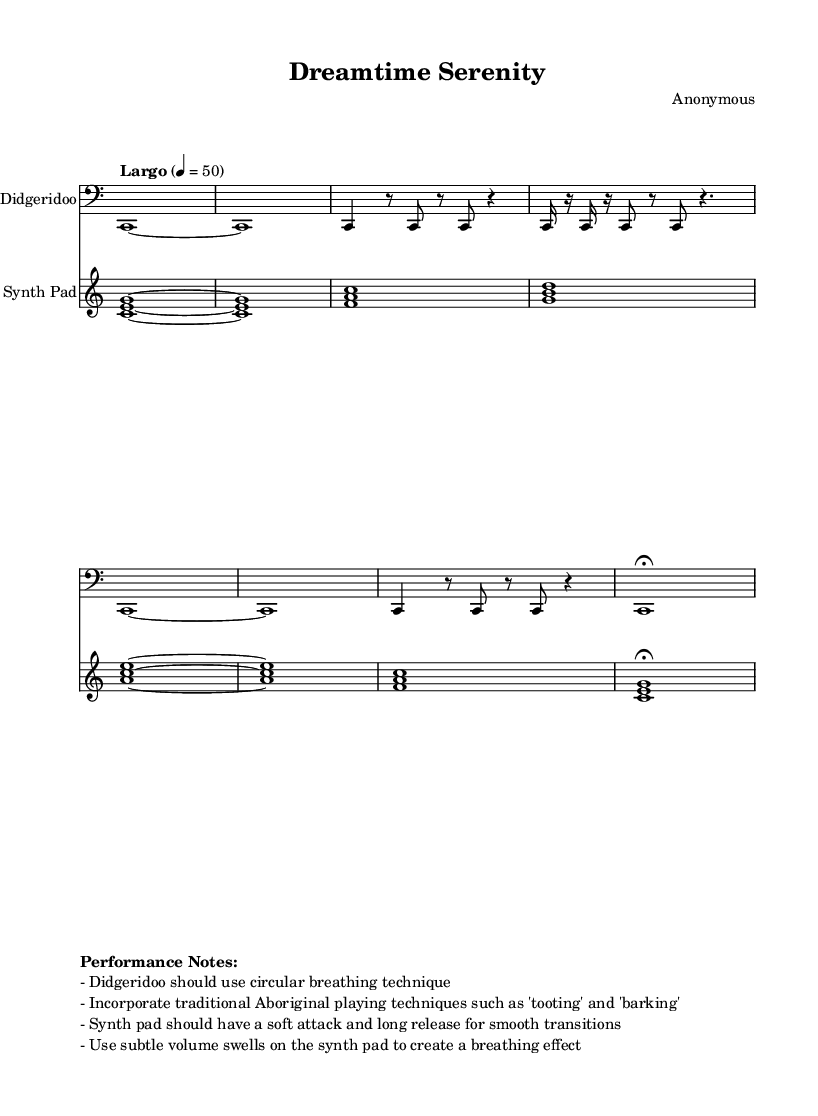What is the time signature of this music? The time signature is indicated at the beginning of the score, which is 4/4. This means there are four beats in each measure, and a quarter note gets one beat.
Answer: 4/4 What is the tempo marking for this piece? The tempo marking is found at the beginning of the score, indicating a Largo tempo, which means a slow pace. The specific beats per minute are set to 50.
Answer: Largo What instrument plays the main melody? The instrument labeled at the beginning of the staff playing the main melody is the Didgeridoo. This is the first staff shown in the score, which is clearly marked.
Answer: Didgeridoo How many measures are in the introduction section of the Didgeridoo part? Counting the measures in the Didgeridoo section's introduction, we see there are 2 measures (the first two lines of the music). Each measure is defined by vertical bar lines.
Answer: 2 What is the playing technique indicated for the Didgeridoo? The performance notes state that the Didgeridoo should use the circular breathing technique. This technique helps to create a continuous sound without stopping to take a breath.
Answer: Circular breathing What type of chords does the Synth Pad part start with? The Synth Pad part begins with a triad chord made up of the notes C, E, and G. These notes are indicated to be played together at the beginning of the score.
Answer: Triad How is the dynamic instruction for the Synth Pad specified? The performance notes instruct that the Synth Pad should have a soft attack and long release. This imparts a smooth and gentle quality to the sound, suitable for ambient music.
Answer: Soft attack and long release 